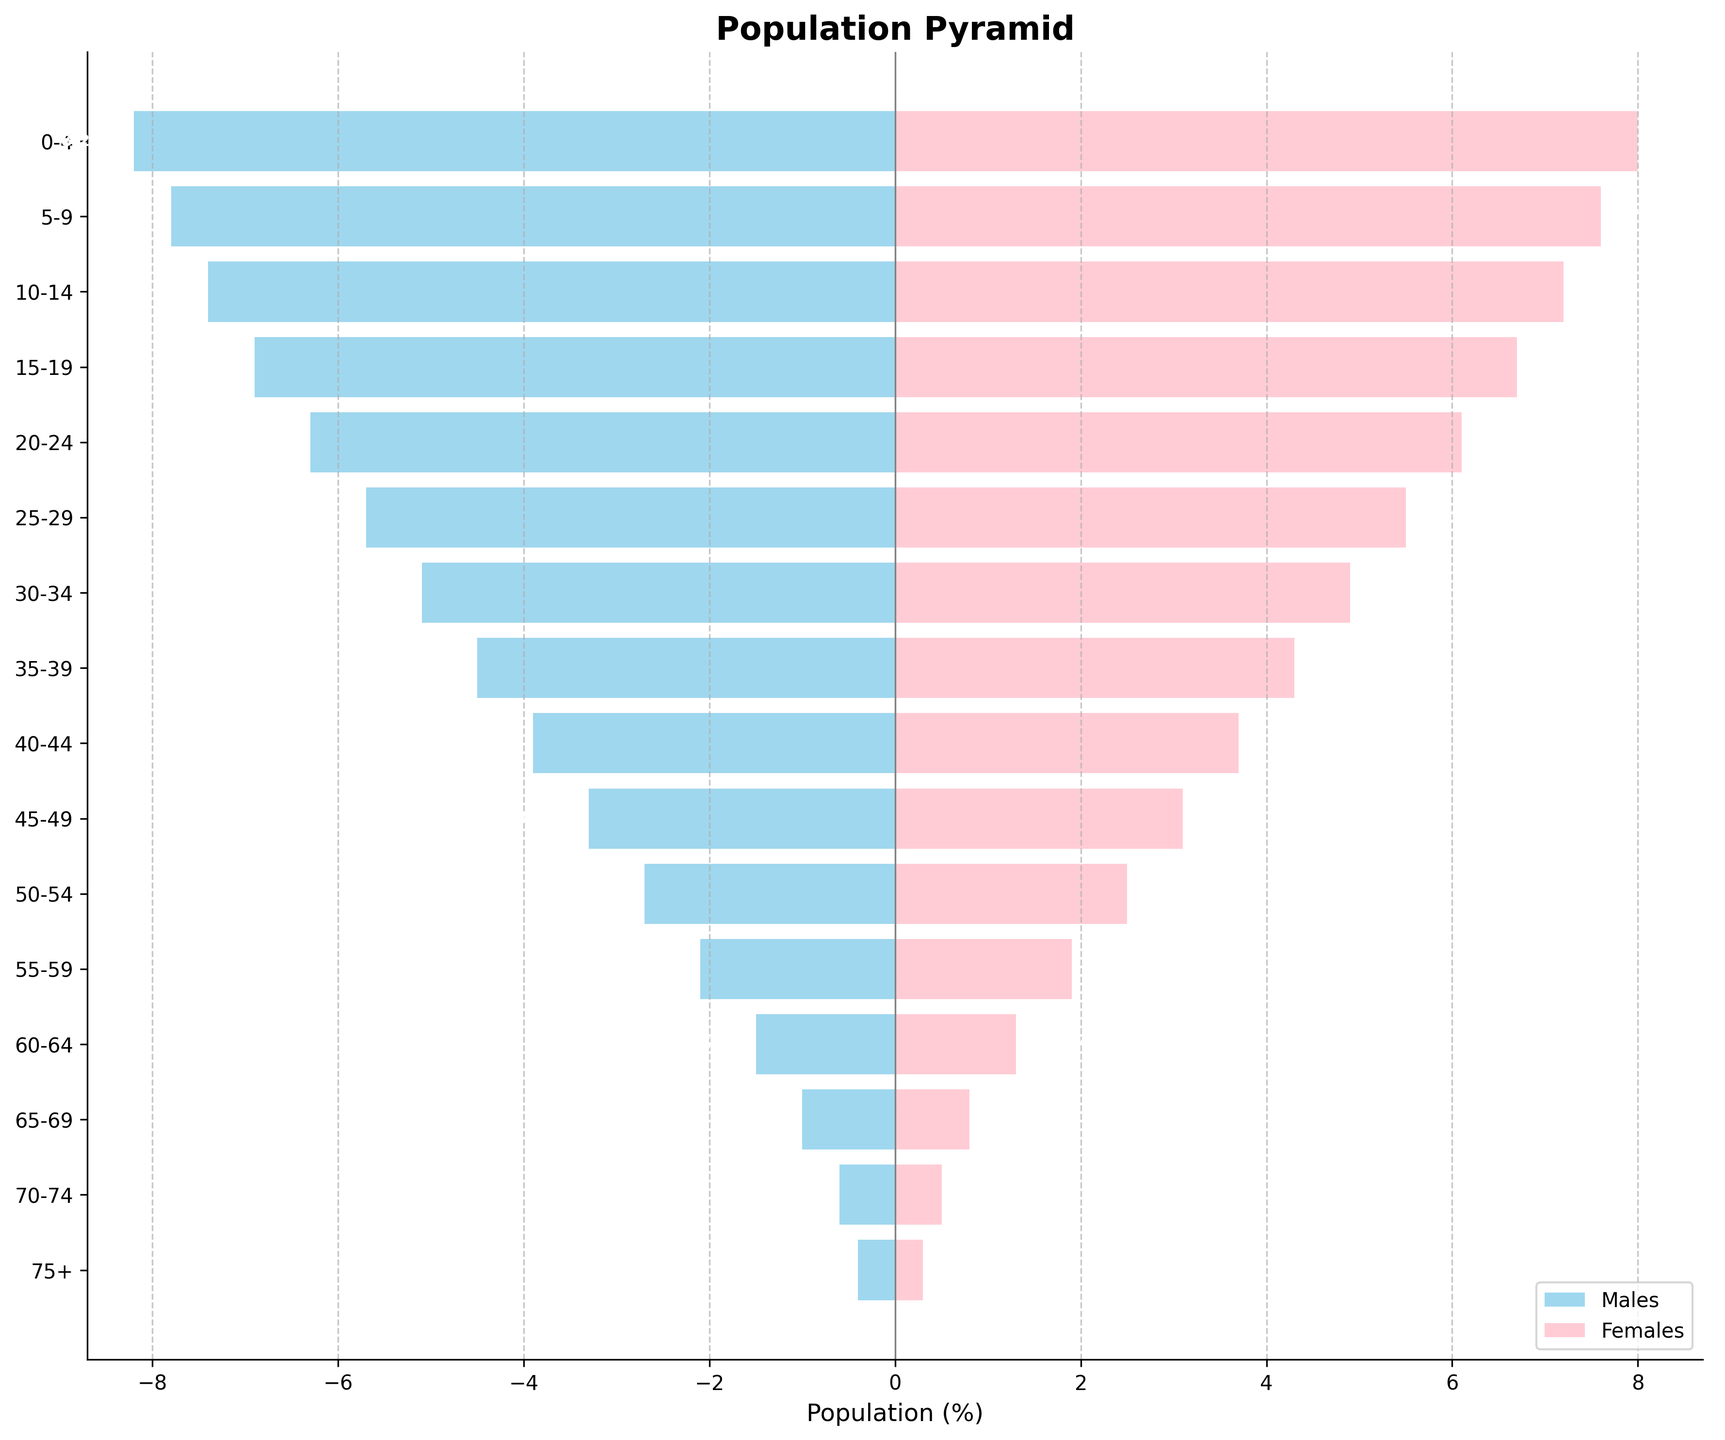What is the title of the figure? The title of the figure is placed directly above the plot and is usually the most prominent text. In this case, it reads "Population Pyramid"
Answer: Population Pyramid Which gender has a larger population in the age group 0-4? For age group 0-4, the bars indicate that the percentage of males (8.2%) is slightly higher than that of females (8.0%)
Answer: Males How does the population of females in the age group 75+ compare to that of males? The bar for females in the age group 75+ reaches 0.3%, whereas the bar for males reaches 0.4%. Therefore, the male population is higher
Answer: Males What is the age group with the highest population for females? By examining the length of the bars for females, the age group 0-4 has the longest bar, indicating the highest population at 8.0%
Answer: 0-4 What is the difference in population between males and females in the age group 20-24? The male population in age group 20-24 is 6.3%, and the female population is 6.1%. The difference is 6.3% - 6.1% = 0.2%
Answer: 0.2% Is there a noticeable trend in the population of males and females as the age groups increase? Both male and female populations trend downwards as age increases from 0-4 to 75+, indicating a decreasing population percentage with older age groups
Answer: Decreasing Which age group has the smallest gender disparity, and what is the difference? The age group 0-4 has the smallest disparity at 0.2%, with males at 8.2% and females at 8.0% (8.2% - 8.0% = 0.2%)
Answer: 0-4, 0.2% How many age groups are represented in the figure? Counting the y-axis labels or bars, we see there are 16 age groups ranging from "0-4" to "75+"
Answer: 16 Are there any age groups where the female population is higher than the male population? By visually scanning the bars, no age groups have a higher percentage of females than males; males are consistently slightly higher in each group
Answer: No Between which two consecutive age groups is the largest drop in the female population observed? Observing the length of bars for consecutive age groups, the largest drop for females is between age groups 10-14 (7.2%) and 15-19 (6.7%), a drop of 0.5%
Answer: 10-14 and 15-19 